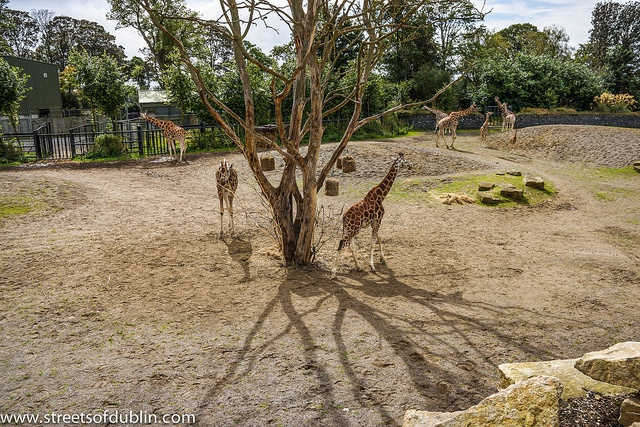Describe the objects in this image and their specific colors. I can see giraffe in gray, black, maroon, and tan tones, giraffe in gray, maroon, and tan tones, giraffe in gray, black, and tan tones, giraffe in gray, tan, and maroon tones, and giraffe in gray and tan tones in this image. 